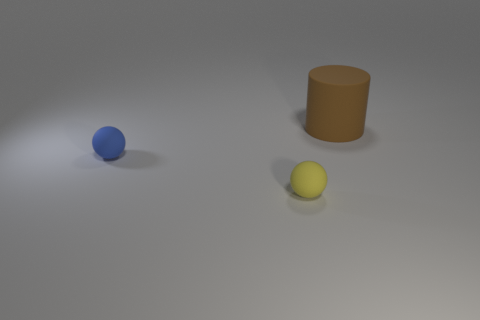Add 2 yellow rubber balls. How many objects exist? 5 Subtract all cylinders. How many objects are left? 2 Subtract all small blue spheres. Subtract all tiny blue rubber balls. How many objects are left? 1 Add 2 big things. How many big things are left? 3 Add 2 small blue matte balls. How many small blue matte balls exist? 3 Subtract 0 brown spheres. How many objects are left? 3 